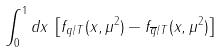Convert formula to latex. <formula><loc_0><loc_0><loc_500><loc_500>\int _ { 0 } ^ { 1 } d x \, \left [ f _ { q / T } ( x , \mu ^ { 2 } ) - f _ { \overline { q } / T } ( x , \mu ^ { 2 } ) \right ]</formula> 